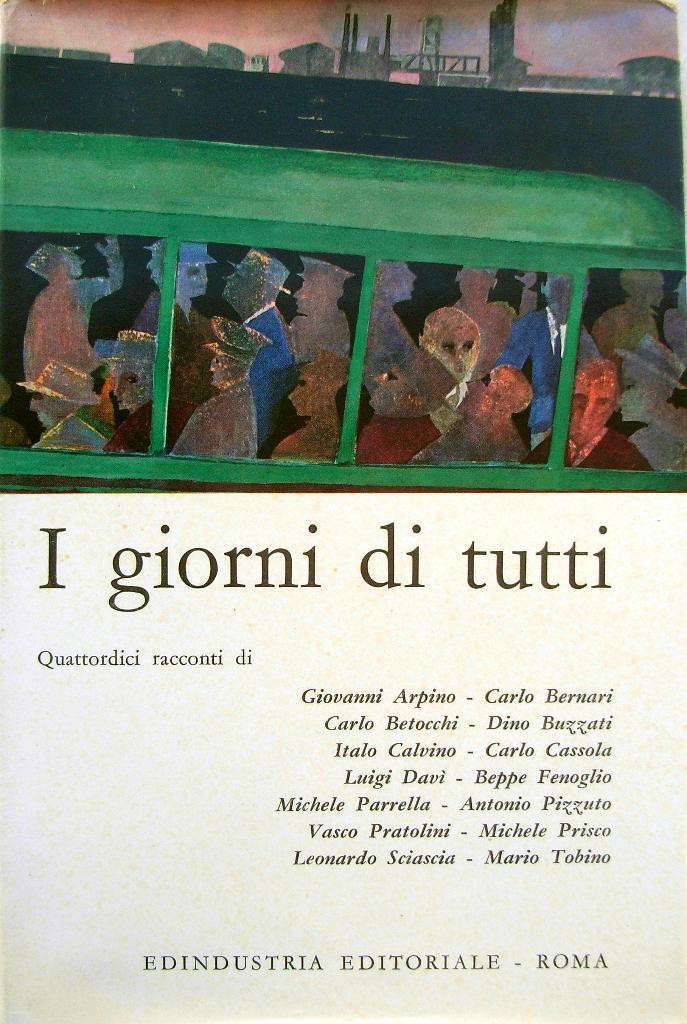Can you describe this image briefly? In this image we can see group of people and some text on it. 